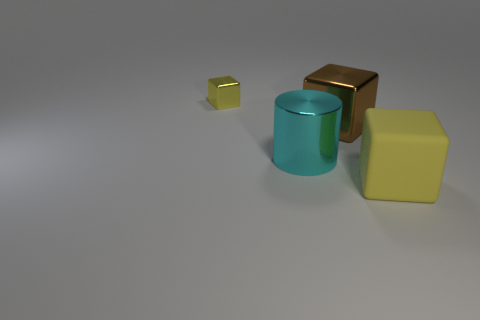Is there anything else that is the same shape as the large cyan object?
Offer a terse response. No. There is a matte thing that is the same shape as the brown metal object; what color is it?
Ensure brevity in your answer.  Yellow. How big is the yellow metal cube?
Your answer should be very brief. Small. There is a big cube that is behind the block that is in front of the big metallic cube; what color is it?
Provide a short and direct response. Brown. What number of things are both in front of the small metal object and behind the big yellow object?
Keep it short and to the point. 2. Is the number of cyan shiny things greater than the number of purple shiny cubes?
Ensure brevity in your answer.  Yes. What material is the small yellow object?
Offer a very short reply. Metal. There is a yellow block that is in front of the big brown metallic cube; what number of large objects are to the left of it?
Your answer should be compact. 2. There is a rubber block; is its color the same as the big metallic thing behind the metal cylinder?
Offer a very short reply. No. There is a metallic cylinder that is the same size as the yellow rubber object; what color is it?
Your response must be concise. Cyan. 